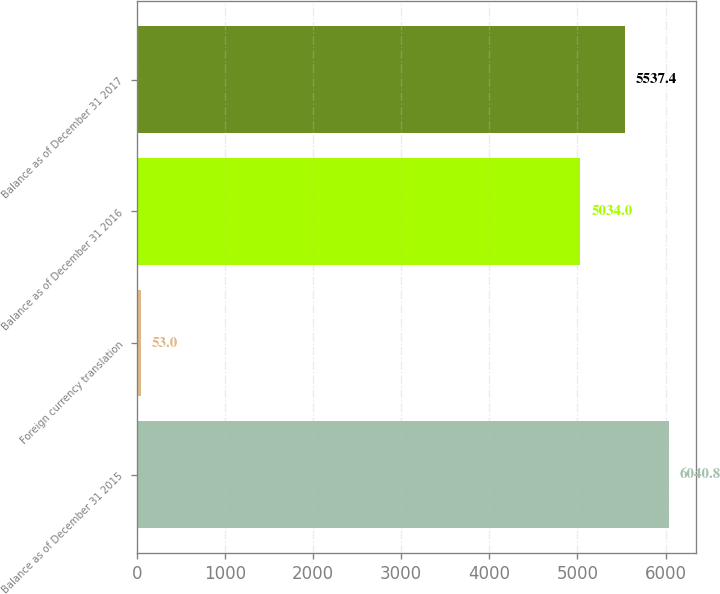Convert chart. <chart><loc_0><loc_0><loc_500><loc_500><bar_chart><fcel>Balance as of December 31 2015<fcel>Foreign currency translation<fcel>Balance as of December 31 2016<fcel>Balance as of December 31 2017<nl><fcel>6040.8<fcel>53<fcel>5034<fcel>5537.4<nl></chart> 